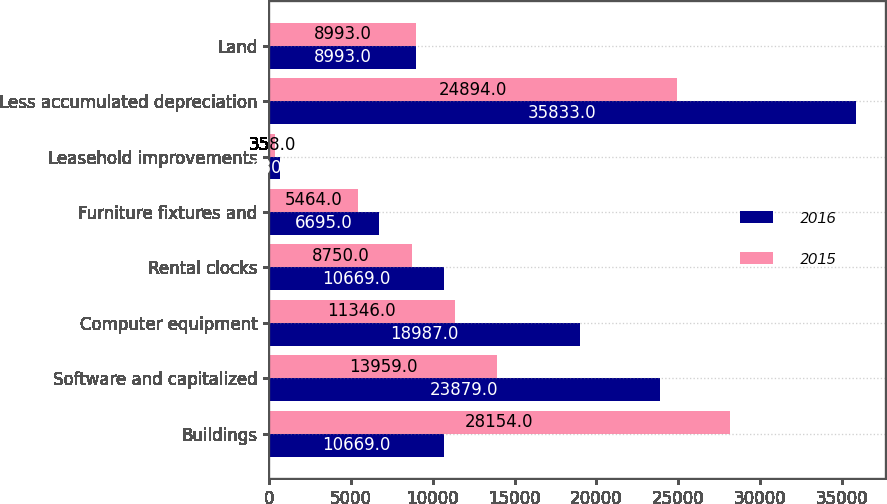Convert chart. <chart><loc_0><loc_0><loc_500><loc_500><stacked_bar_chart><ecel><fcel>Buildings<fcel>Software and capitalized<fcel>Computer equipment<fcel>Rental clocks<fcel>Furniture fixtures and<fcel>Leasehold improvements<fcel>Less accumulated depreciation<fcel>Land<nl><fcel>2016<fcel>10669<fcel>23879<fcel>18987<fcel>10669<fcel>6695<fcel>680<fcel>35833<fcel>8993<nl><fcel>2015<fcel>28154<fcel>13959<fcel>11346<fcel>8750<fcel>5464<fcel>358<fcel>24894<fcel>8993<nl></chart> 